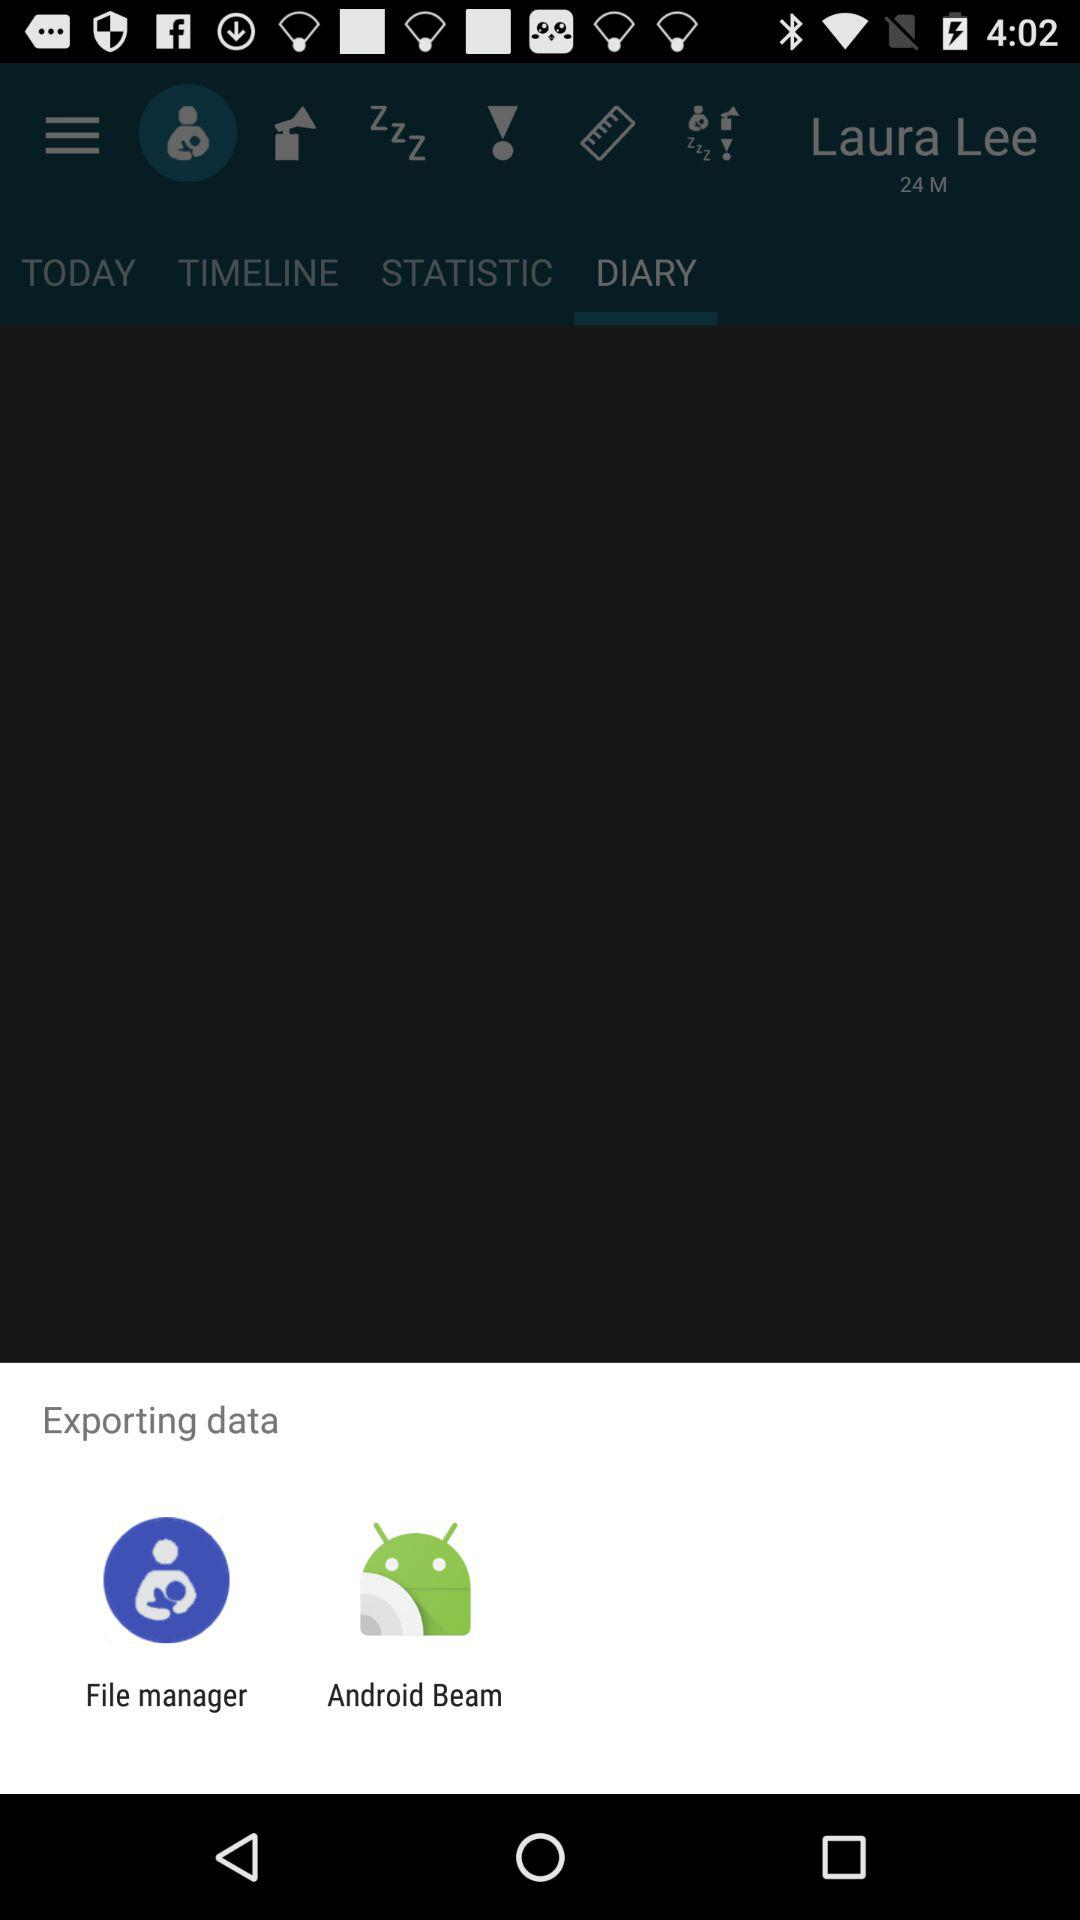What is the gender of the user? The gender of the user is male. 